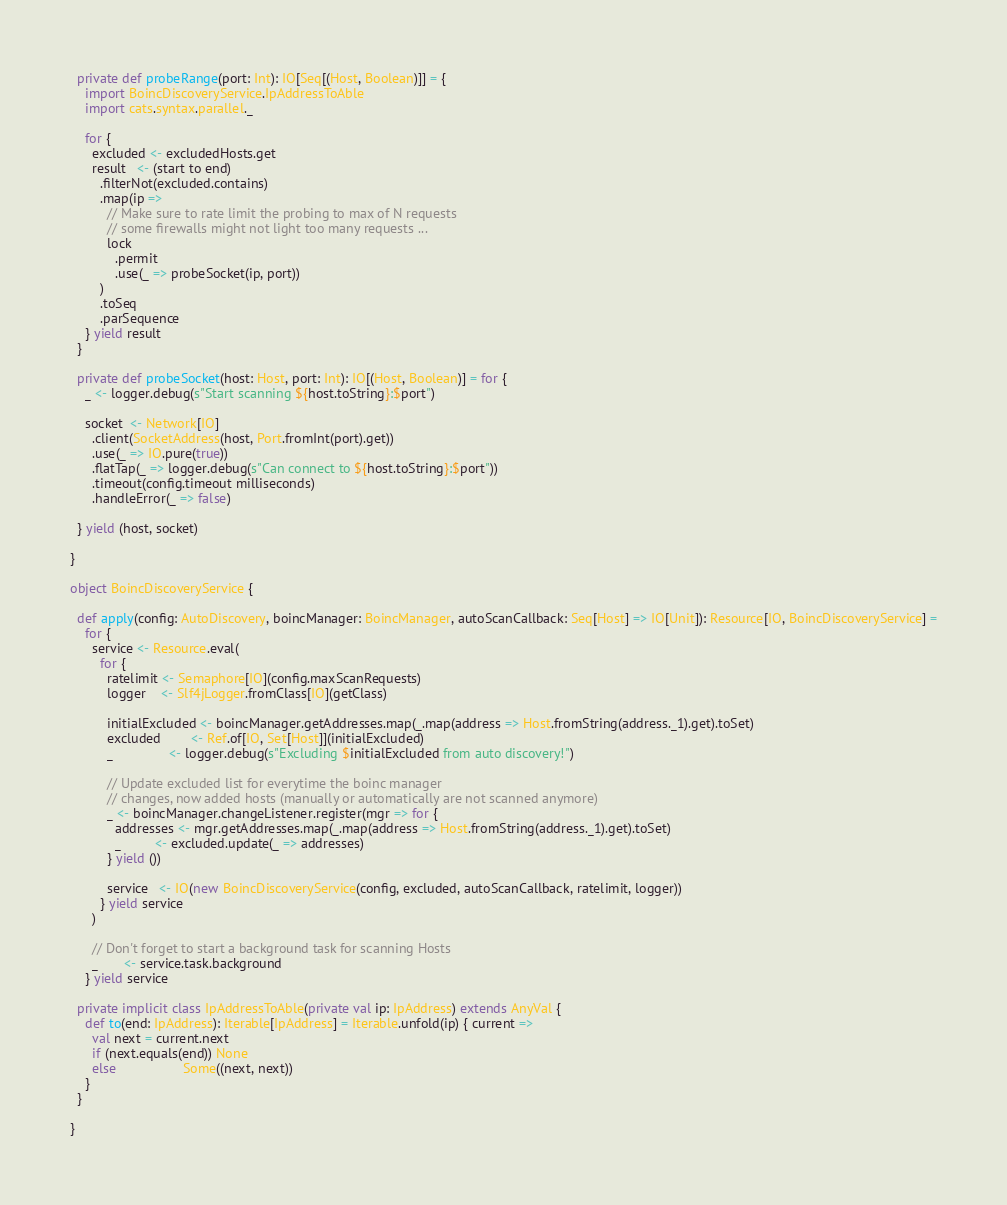Convert code to text. <code><loc_0><loc_0><loc_500><loc_500><_Scala_>
  private def probeRange(port: Int): IO[Seq[(Host, Boolean)]] = {
    import BoincDiscoveryService.IpAddressToAble
    import cats.syntax.parallel._

    for {
      excluded <- excludedHosts.get
      result   <- (start to end)
        .filterNot(excluded.contains)
        .map(ip =>
          // Make sure to rate limit the probing to max of N requests
          // some firewalls might not light too many requests ...
          lock
            .permit
            .use(_ => probeSocket(ip, port))
        )
        .toSeq
        .parSequence
    } yield result
  }

  private def probeSocket(host: Host, port: Int): IO[(Host, Boolean)] = for {
    _ <- logger.debug(s"Start scanning ${host.toString}:$port")

    socket  <- Network[IO]
      .client(SocketAddress(host, Port.fromInt(port).get))
      .use(_ => IO.pure(true))
      .flatTap(_ => logger.debug(s"Can connect to ${host.toString}:$port"))
      .timeout(config.timeout milliseconds)
      .handleError(_ => false)

  } yield (host, socket)

}

object BoincDiscoveryService {

  def apply(config: AutoDiscovery, boincManager: BoincManager, autoScanCallback: Seq[Host] => IO[Unit]): Resource[IO, BoincDiscoveryService] =
    for {
      service <- Resource.eval(
        for {
          ratelimit <- Semaphore[IO](config.maxScanRequests)
          logger    <- Slf4jLogger.fromClass[IO](getClass)

          initialExcluded <- boincManager.getAddresses.map(_.map(address => Host.fromString(address._1).get).toSet)
          excluded        <- Ref.of[IO, Set[Host]](initialExcluded)
          _               <- logger.debug(s"Excluding $initialExcluded from auto discovery!")

          // Update excluded list for everytime the boinc manager
          // changes, now added hosts (manually or automatically are not scanned anymore)
          _ <- boincManager.changeListener.register(mgr => for {
            addresses <- mgr.getAddresses.map(_.map(address => Host.fromString(address._1).get).toSet)
            _         <- excluded.update(_ => addresses)
          } yield ())

          service   <- IO(new BoincDiscoveryService(config, excluded, autoScanCallback, ratelimit, logger))
        } yield service
      )

      // Don't forget to start a background task for scanning Hosts
      _       <- service.task.background
    } yield service

  private implicit class IpAddressToAble(private val ip: IpAddress) extends AnyVal {
    def to(end: IpAddress): Iterable[IpAddress] = Iterable.unfold(ip) { current =>
      val next = current.next
      if (next.equals(end)) None
      else                  Some((next, next))
    }
  }

}
</code> 